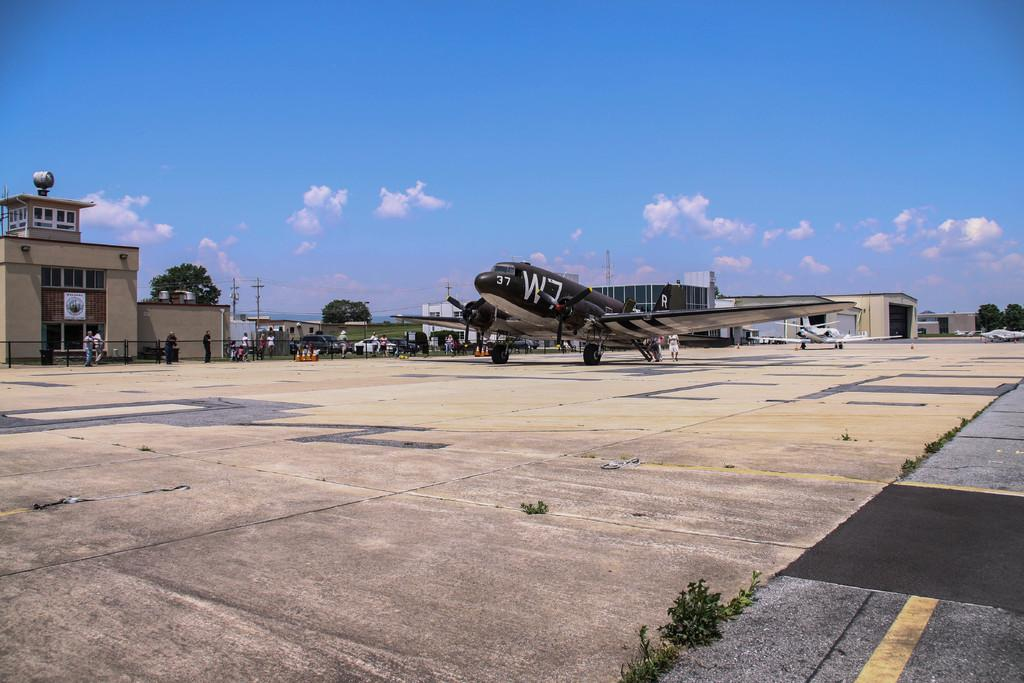<image>
Share a concise interpretation of the image provided. a black and grey airplane sitting on a runway with W7 in bold on the side. 